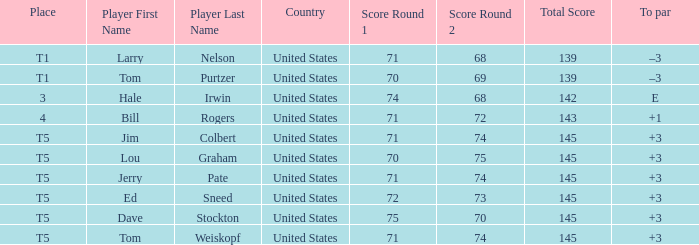Who is the player with a t5 place and a 75-70=145 score? Dave Stockton. 